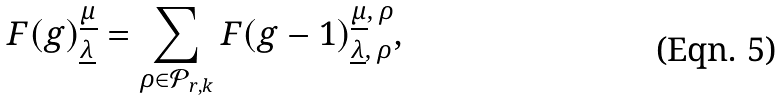<formula> <loc_0><loc_0><loc_500><loc_500>F ( g ) _ { \underline { \lambda } } ^ { \underline { \mu } } = \sum _ { \rho \in { \mathcal { P } } _ { r , k } } F ( g - 1 ) _ { \underline { \lambda } , \, \rho } ^ { \underline { \mu } , \, \rho } ,</formula> 